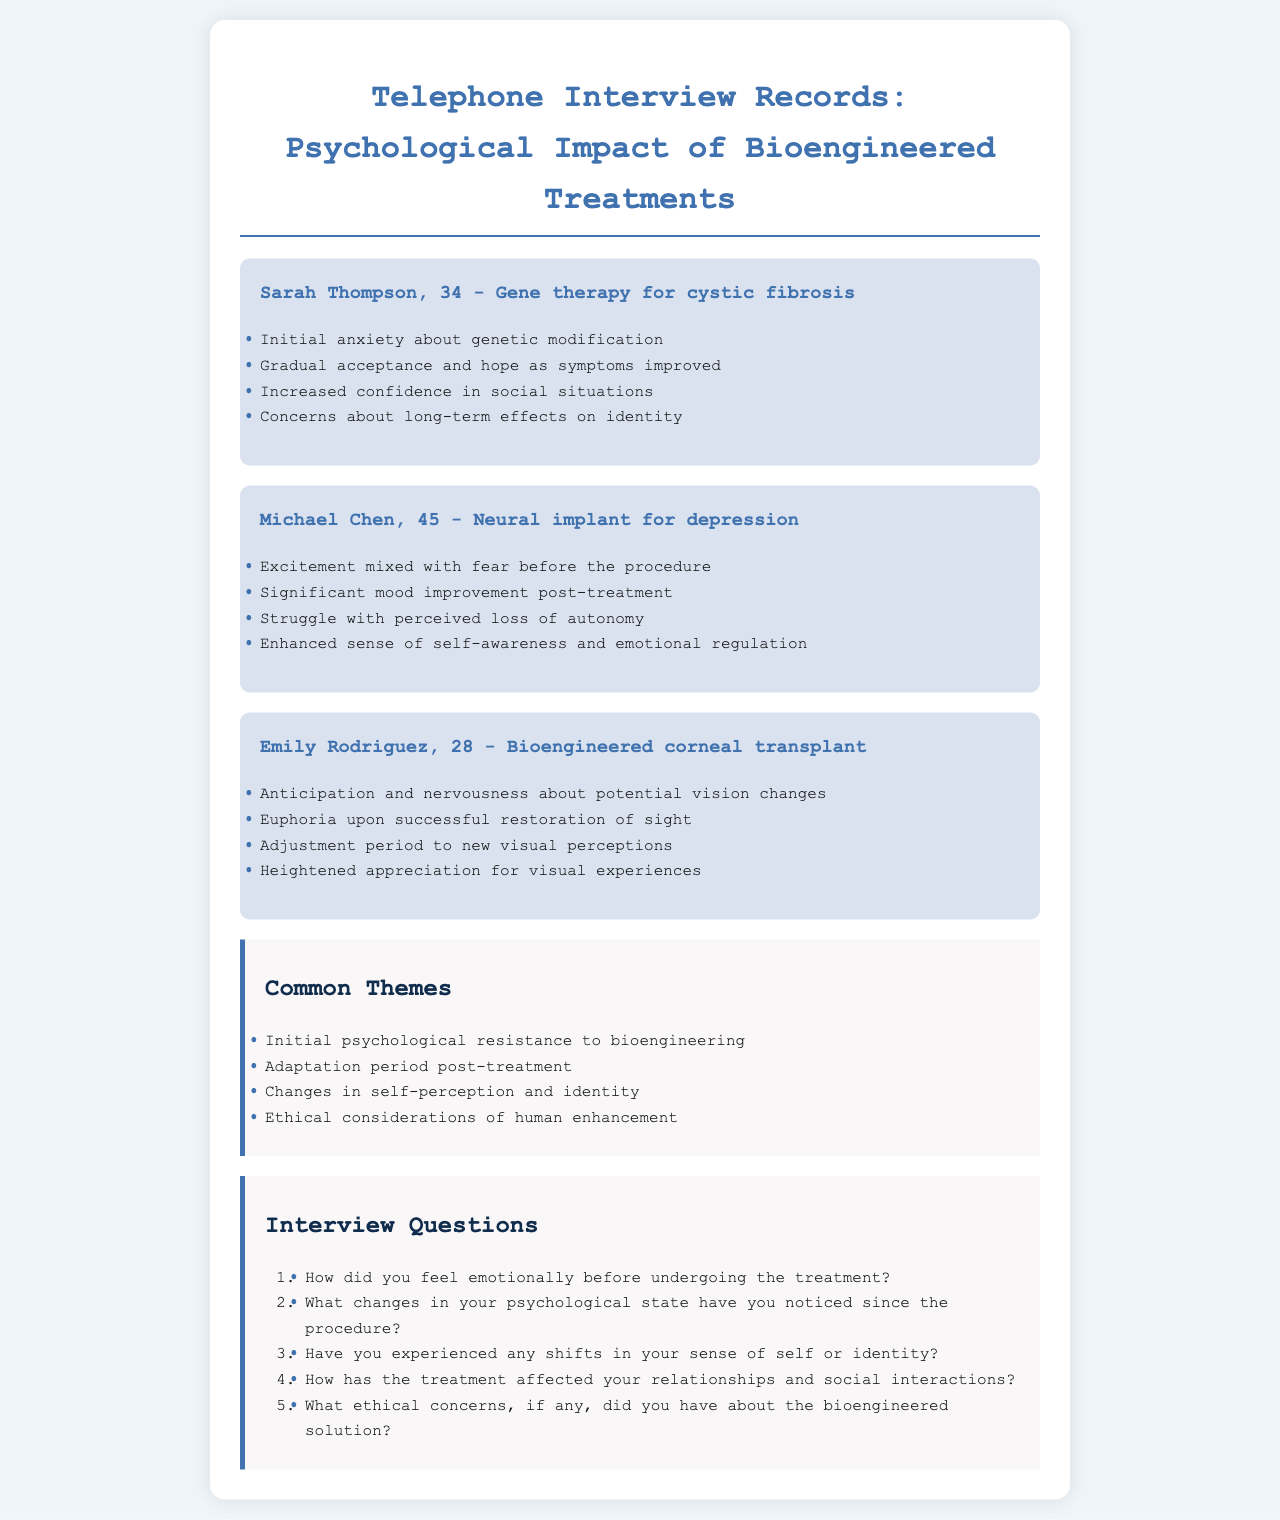What is the name of the first interviewee? The name of the first interviewee is mentioned at the beginning of the first interview section.
Answer: Sarah Thompson What age is Michael Chen? Michael Chen's age is specified in the header of his interview section.
Answer: 45 What treatment did Emily Rodriguez undergo? The type of treatment Emily Rodriguez had is documented in her interview section.
Answer: Bioengineered corneal transplant What common theme is related to self-perception? The themes section lists various themes, including changes in self-perception mentioned specifically.
Answer: Changes in self-perception and identity What emotions did Sarah Thompson experience initially? Sarah Thompson's initial emotions are listed in her interview points.
Answer: Initial anxiety about genetic modification How did Michael Chen's mood change post-treatment? The change in Michael Chen's mood after treatment is clearly stated in his interview section.
Answer: Significant mood improvement post-treatment What ethical concerns did the interviewees have? Ethical considerations are highlighted in the common themes, indicating that interviewees expressed concerns.
Answer: Ethical considerations of human enhancement How many distinct interviewees are documented in the telephone records? The number of interviewees is determined by counting the interview sections provided.
Answer: 3 How does Emily Rodriguez describe her feelings post-treatment? Emily Rodriguez's feelings after the treatment can be found among her listed experiences.
Answer: Euphoria upon successful restoration of sight 